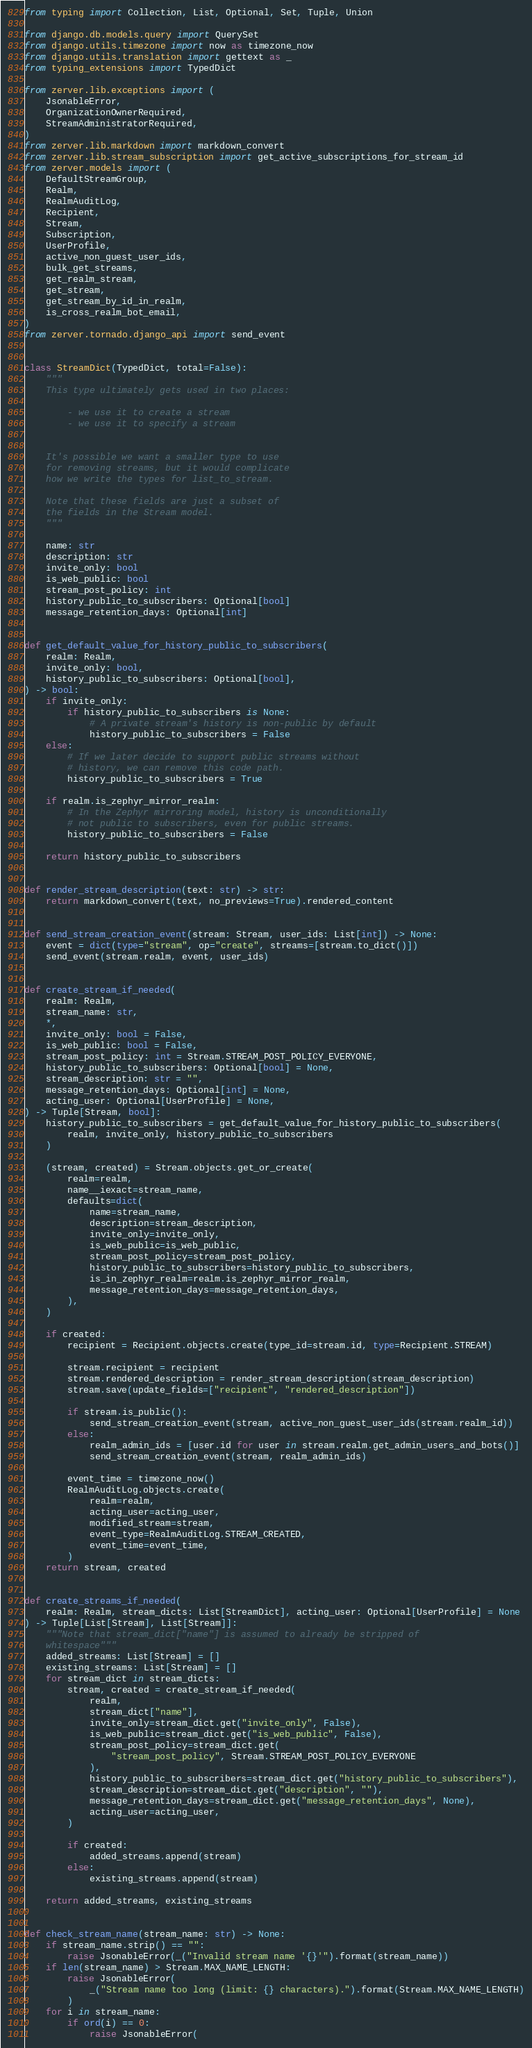Convert code to text. <code><loc_0><loc_0><loc_500><loc_500><_Python_>from typing import Collection, List, Optional, Set, Tuple, Union

from django.db.models.query import QuerySet
from django.utils.timezone import now as timezone_now
from django.utils.translation import gettext as _
from typing_extensions import TypedDict

from zerver.lib.exceptions import (
    JsonableError,
    OrganizationOwnerRequired,
    StreamAdministratorRequired,
)
from zerver.lib.markdown import markdown_convert
from zerver.lib.stream_subscription import get_active_subscriptions_for_stream_id
from zerver.models import (
    DefaultStreamGroup,
    Realm,
    RealmAuditLog,
    Recipient,
    Stream,
    Subscription,
    UserProfile,
    active_non_guest_user_ids,
    bulk_get_streams,
    get_realm_stream,
    get_stream,
    get_stream_by_id_in_realm,
    is_cross_realm_bot_email,
)
from zerver.tornado.django_api import send_event


class StreamDict(TypedDict, total=False):
    """
    This type ultimately gets used in two places:

        - we use it to create a stream
        - we use it to specify a stream


    It's possible we want a smaller type to use
    for removing streams, but it would complicate
    how we write the types for list_to_stream.

    Note that these fields are just a subset of
    the fields in the Stream model.
    """

    name: str
    description: str
    invite_only: bool
    is_web_public: bool
    stream_post_policy: int
    history_public_to_subscribers: Optional[bool]
    message_retention_days: Optional[int]


def get_default_value_for_history_public_to_subscribers(
    realm: Realm,
    invite_only: bool,
    history_public_to_subscribers: Optional[bool],
) -> bool:
    if invite_only:
        if history_public_to_subscribers is None:
            # A private stream's history is non-public by default
            history_public_to_subscribers = False
    else:
        # If we later decide to support public streams without
        # history, we can remove this code path.
        history_public_to_subscribers = True

    if realm.is_zephyr_mirror_realm:
        # In the Zephyr mirroring model, history is unconditionally
        # not public to subscribers, even for public streams.
        history_public_to_subscribers = False

    return history_public_to_subscribers


def render_stream_description(text: str) -> str:
    return markdown_convert(text, no_previews=True).rendered_content


def send_stream_creation_event(stream: Stream, user_ids: List[int]) -> None:
    event = dict(type="stream", op="create", streams=[stream.to_dict()])
    send_event(stream.realm, event, user_ids)


def create_stream_if_needed(
    realm: Realm,
    stream_name: str,
    *,
    invite_only: bool = False,
    is_web_public: bool = False,
    stream_post_policy: int = Stream.STREAM_POST_POLICY_EVERYONE,
    history_public_to_subscribers: Optional[bool] = None,
    stream_description: str = "",
    message_retention_days: Optional[int] = None,
    acting_user: Optional[UserProfile] = None,
) -> Tuple[Stream, bool]:
    history_public_to_subscribers = get_default_value_for_history_public_to_subscribers(
        realm, invite_only, history_public_to_subscribers
    )

    (stream, created) = Stream.objects.get_or_create(
        realm=realm,
        name__iexact=stream_name,
        defaults=dict(
            name=stream_name,
            description=stream_description,
            invite_only=invite_only,
            is_web_public=is_web_public,
            stream_post_policy=stream_post_policy,
            history_public_to_subscribers=history_public_to_subscribers,
            is_in_zephyr_realm=realm.is_zephyr_mirror_realm,
            message_retention_days=message_retention_days,
        ),
    )

    if created:
        recipient = Recipient.objects.create(type_id=stream.id, type=Recipient.STREAM)

        stream.recipient = recipient
        stream.rendered_description = render_stream_description(stream_description)
        stream.save(update_fields=["recipient", "rendered_description"])

        if stream.is_public():
            send_stream_creation_event(stream, active_non_guest_user_ids(stream.realm_id))
        else:
            realm_admin_ids = [user.id for user in stream.realm.get_admin_users_and_bots()]
            send_stream_creation_event(stream, realm_admin_ids)

        event_time = timezone_now()
        RealmAuditLog.objects.create(
            realm=realm,
            acting_user=acting_user,
            modified_stream=stream,
            event_type=RealmAuditLog.STREAM_CREATED,
            event_time=event_time,
        )
    return stream, created


def create_streams_if_needed(
    realm: Realm, stream_dicts: List[StreamDict], acting_user: Optional[UserProfile] = None
) -> Tuple[List[Stream], List[Stream]]:
    """Note that stream_dict["name"] is assumed to already be stripped of
    whitespace"""
    added_streams: List[Stream] = []
    existing_streams: List[Stream] = []
    for stream_dict in stream_dicts:
        stream, created = create_stream_if_needed(
            realm,
            stream_dict["name"],
            invite_only=stream_dict.get("invite_only", False),
            is_web_public=stream_dict.get("is_web_public", False),
            stream_post_policy=stream_dict.get(
                "stream_post_policy", Stream.STREAM_POST_POLICY_EVERYONE
            ),
            history_public_to_subscribers=stream_dict.get("history_public_to_subscribers"),
            stream_description=stream_dict.get("description", ""),
            message_retention_days=stream_dict.get("message_retention_days", None),
            acting_user=acting_user,
        )

        if created:
            added_streams.append(stream)
        else:
            existing_streams.append(stream)

    return added_streams, existing_streams


def check_stream_name(stream_name: str) -> None:
    if stream_name.strip() == "":
        raise JsonableError(_("Invalid stream name '{}'").format(stream_name))
    if len(stream_name) > Stream.MAX_NAME_LENGTH:
        raise JsonableError(
            _("Stream name too long (limit: {} characters).").format(Stream.MAX_NAME_LENGTH)
        )
    for i in stream_name:
        if ord(i) == 0:
            raise JsonableError(</code> 